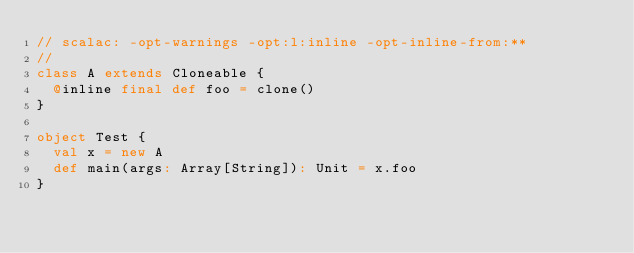<code> <loc_0><loc_0><loc_500><loc_500><_Scala_>// scalac: -opt-warnings -opt:l:inline -opt-inline-from:**
//
class A extends Cloneable {
  @inline final def foo = clone()
}

object Test {
  val x = new A
  def main(args: Array[String]): Unit = x.foo
}
</code> 